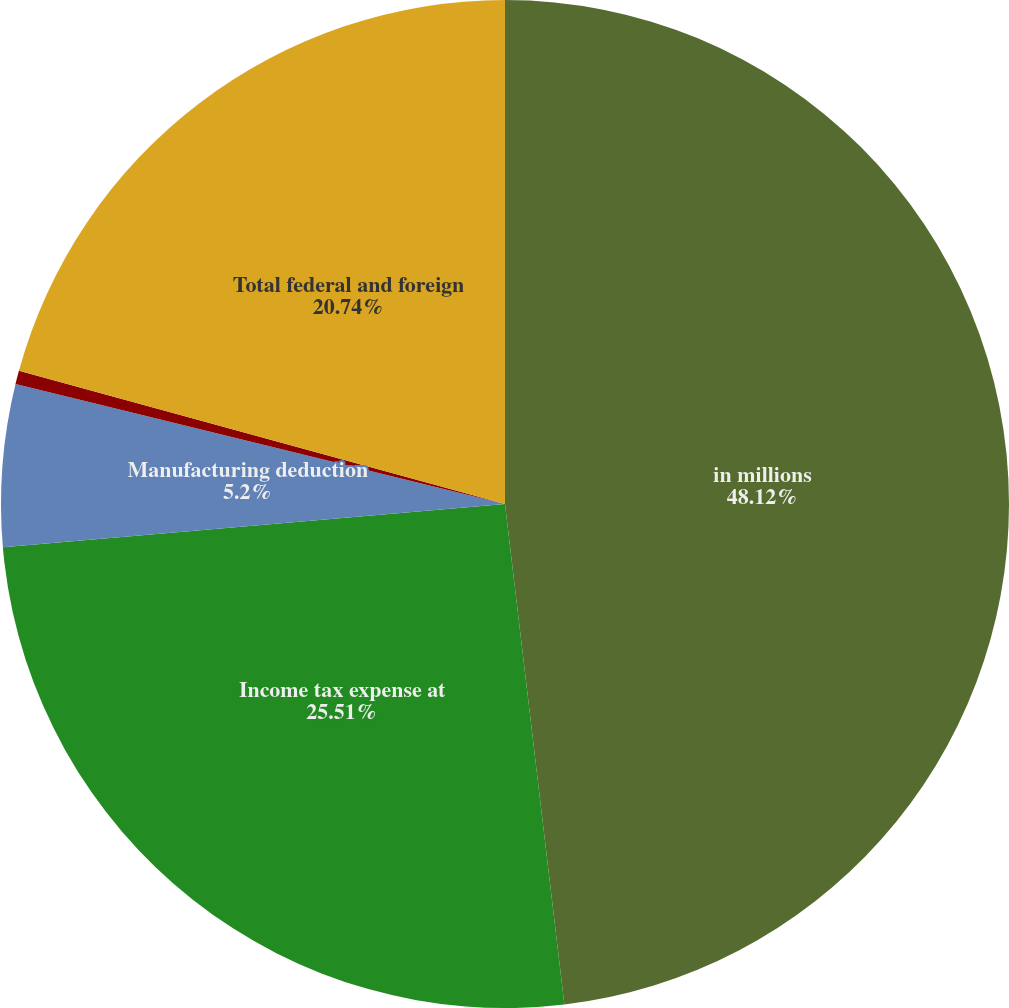<chart> <loc_0><loc_0><loc_500><loc_500><pie_chart><fcel>in millions<fcel>Income tax expense at<fcel>Manufacturing deduction<fcel>Other net<fcel>Total federal and foreign<nl><fcel>48.12%<fcel>25.51%<fcel>5.2%<fcel>0.43%<fcel>20.74%<nl></chart> 